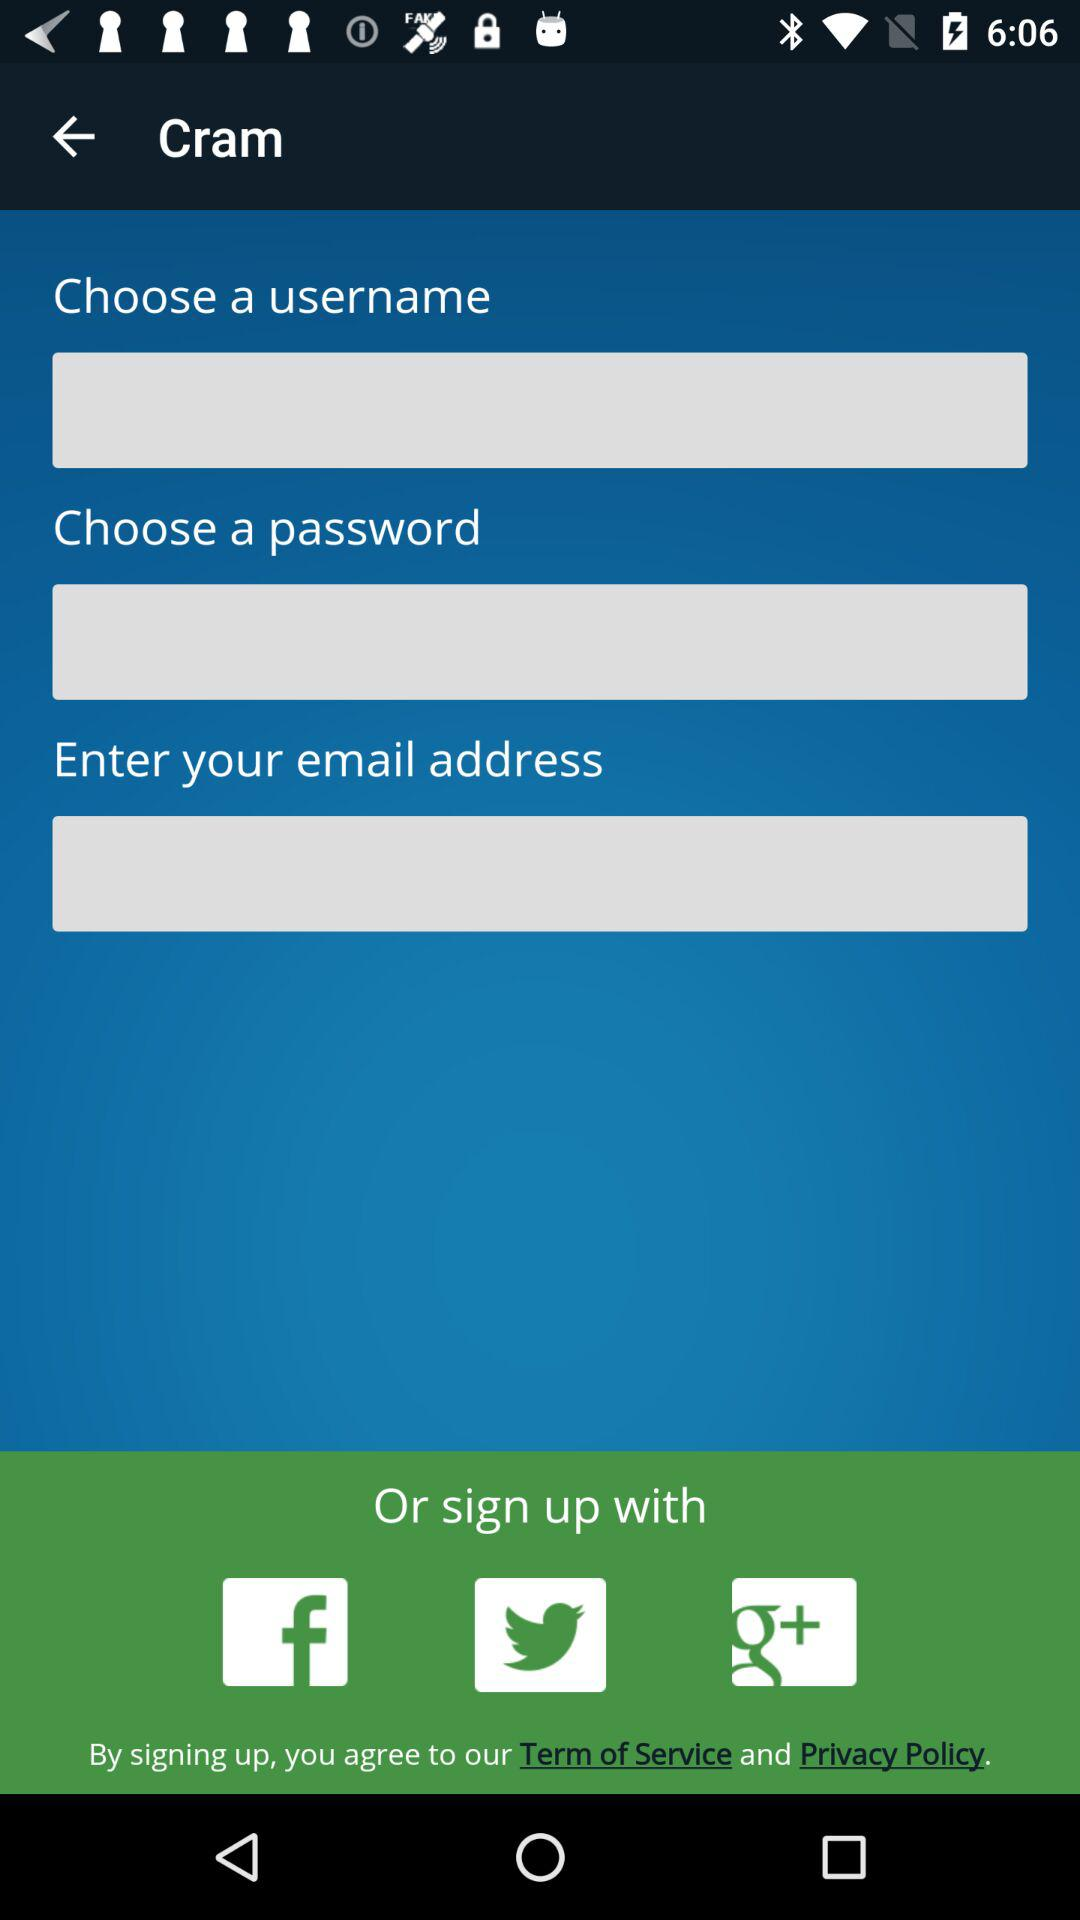How many social media platforms can be used to sign up?
Answer the question using a single word or phrase. 3 